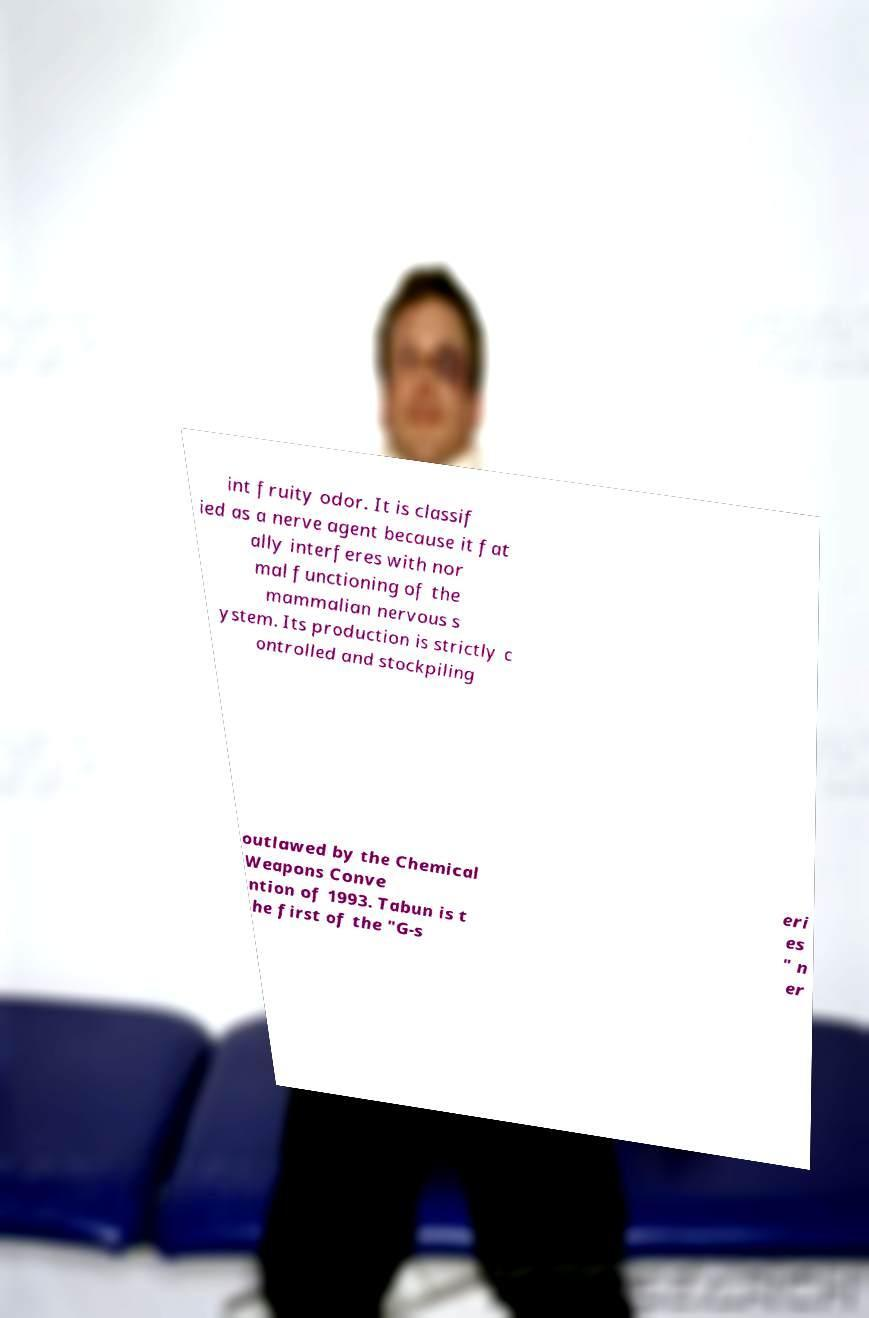Could you assist in decoding the text presented in this image and type it out clearly? int fruity odor. It is classif ied as a nerve agent because it fat ally interferes with nor mal functioning of the mammalian nervous s ystem. Its production is strictly c ontrolled and stockpiling outlawed by the Chemical Weapons Conve ntion of 1993. Tabun is t he first of the "G-s eri es " n er 